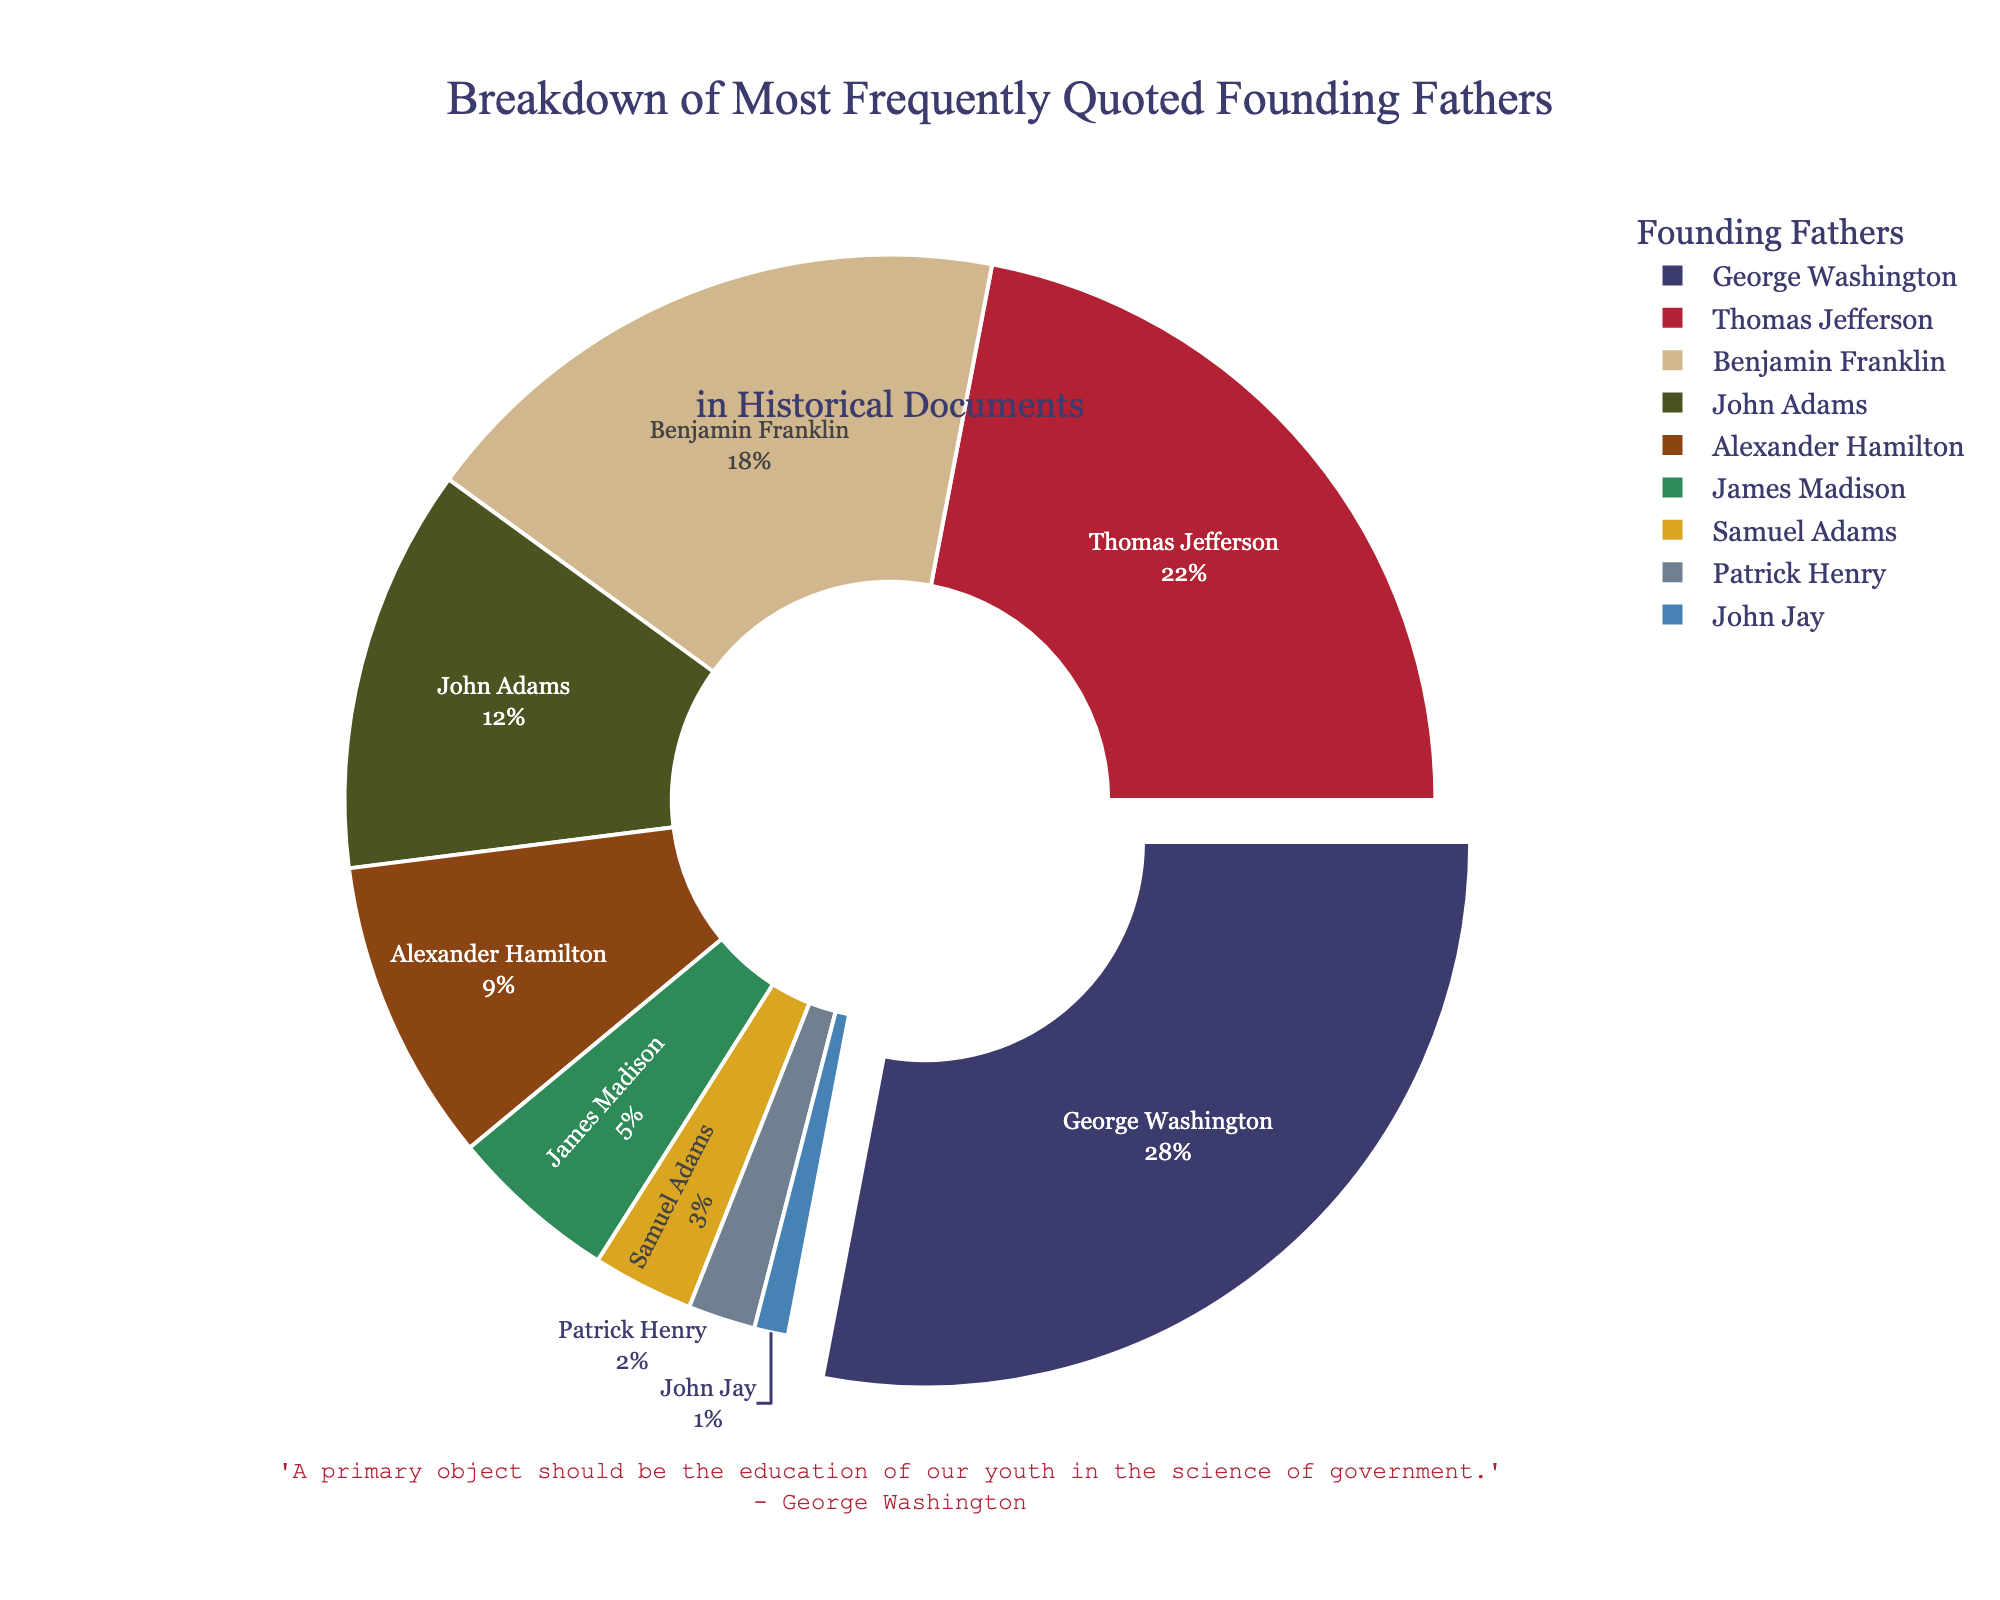What percentage does George Washington contribute to the total quotes? George Washington contributes 28% of the total quotes. This information can be directly observed from the pie chart, where George Washington's segment is labeled with "George Washington 28%".
Answer: 28% Which Founding Father is quoted the least frequently? The Founding Father quoted the least frequently is John Jay, who has the smallest segment in the pie chart labeled with "John Jay 1%".
Answer: John Jay What is the combined percentage of quotes attributed to Thomas Jefferson and Benjamin Franklin? The combined percentage of quotes attributed to Thomas Jefferson and Benjamin Franklin is found by adding their individual percentages: 22% + 18% = 40%.
Answer: 40% How many more percentage points is George Washington quoted than James Madison? George Washington is quoted 28%, and James Madison is quoted 5%. The difference in their percentages is 28% - 5% = 23%.
Answer: 23% What is the median percentage among the founding fathers quoted? To find the median, list the percentages in ascending order: 1%, 2%, 3%, 5%, 9%, 12%, 18%, 22%, 28%. The median percentage is the middle value in this ordered list, which is 9%.
Answer: 9% Which two Founding Fathers have a combined quotation percentage equal to or closest to that of George Washington? George Washington has a percentage of 28%. The combined percentage of Thomas Jefferson (22%) and Samuel Adams (3%) is 25%, which is the closest to 28% without exceeding it.
Answer: Thomas Jefferson and Samuel Adams What is the average percentage quote of the three most frequently quoted Founding Fathers? The three most frequently quoted Founding Fathers are George Washington (28%), Thomas Jefferson (22%), and Benjamin Franklin (18%). The average percentage is calculated as (28% + 22% + 18%)/3 = 68%/3 ≈ 22.67%.
Answer: 22.67% Who are the four most frequently quoted Founding Fathers and what is their combined percentage? The four most frequently quoted Founding Fathers are George Washington (28%), Thomas Jefferson (22%), Benjamin Franklin (18%), and John Adams (12%). Their combined percentage is 28% + 22% + 18% + 12% = 80%.
Answer: George Washington, Thomas Jefferson, Benjamin Franklin, and John Adams; 80% Which Founding Father has a segment pulled out from the pie chart, and why might this be the case? George Washington has a segment pulled out from the pie chart, which is usually done to highlight the category with the highest value or significance.
Answer: George Washington If the total quotations were 1000, how many quotations does Alexander Hamilton have? Alexander Hamilton is quoted at 9%. Therefore, the number of quotations for Alexander Hamilton is 9% of 1000, which is 0.09 * 1000 = 90.
Answer: 90 